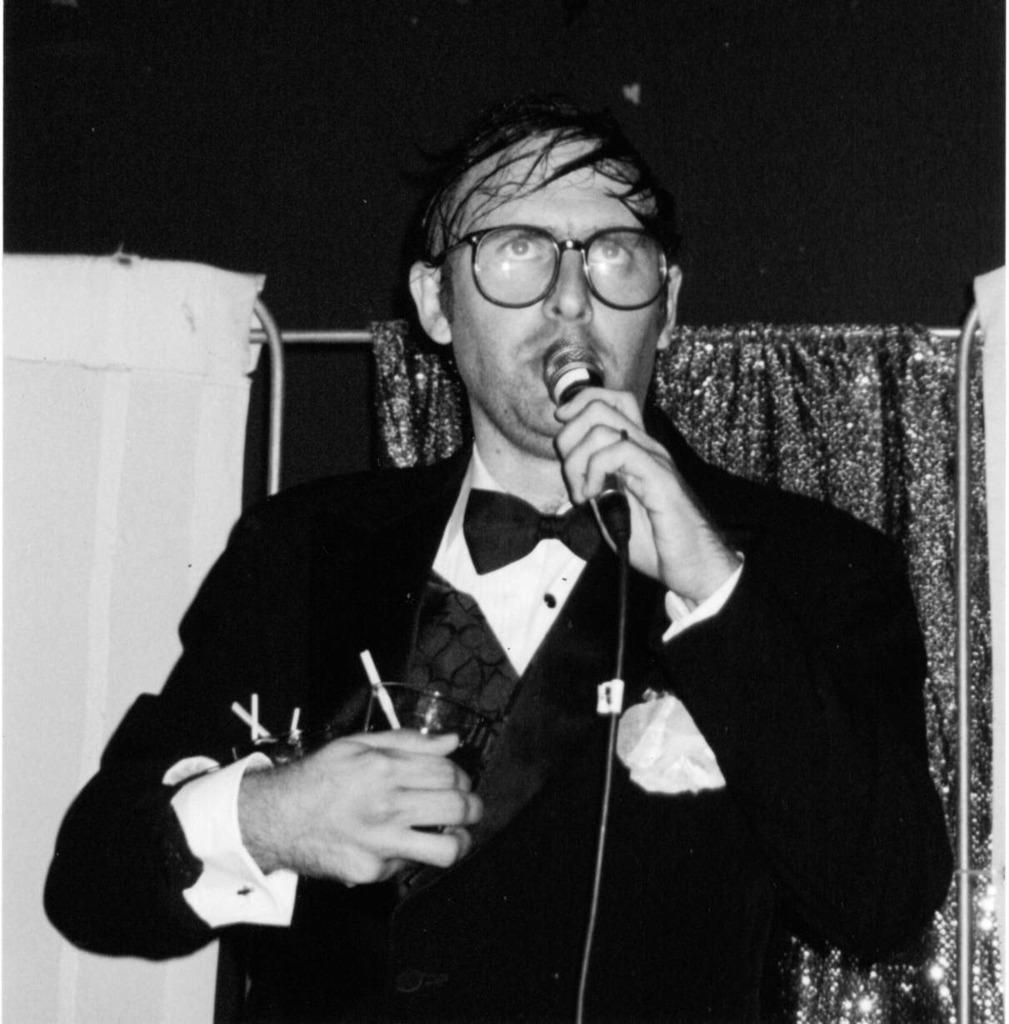Please provide a concise description of this image. in this image one person is standing in middle of this image and wearing a black color dress and holding a mic and there are some curtains in the background. the left side curtain is in white color and this person is holding some objects. 